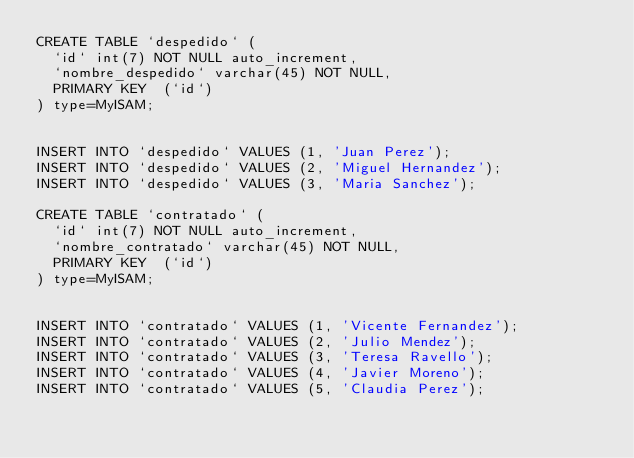<code> <loc_0><loc_0><loc_500><loc_500><_SQL_>CREATE TABLE `despedido` (
  `id` int(7) NOT NULL auto_increment,
  `nombre_despedido` varchar(45) NOT NULL,
  PRIMARY KEY  (`id`)
) type=MyISAM;


INSERT INTO `despedido` VALUES (1, 'Juan Perez');
INSERT INTO `despedido` VALUES (2, 'Miguel Hernandez');
INSERT INTO `despedido` VALUES (3, 'Maria Sanchez');

CREATE TABLE `contratado` (
  `id` int(7) NOT NULL auto_increment,
  `nombre_contratado` varchar(45) NOT NULL,
  PRIMARY KEY  (`id`)
) type=MyISAM;


INSERT INTO `contratado` VALUES (1, 'Vicente Fernandez');
INSERT INTO `contratado` VALUES (2, 'Julio Mendez');
INSERT INTO `contratado` VALUES (3, 'Teresa Ravello');
INSERT INTO `contratado` VALUES (4, 'Javier Moreno');
INSERT INTO `contratado` VALUES (5, 'Claudia Perez');</code> 